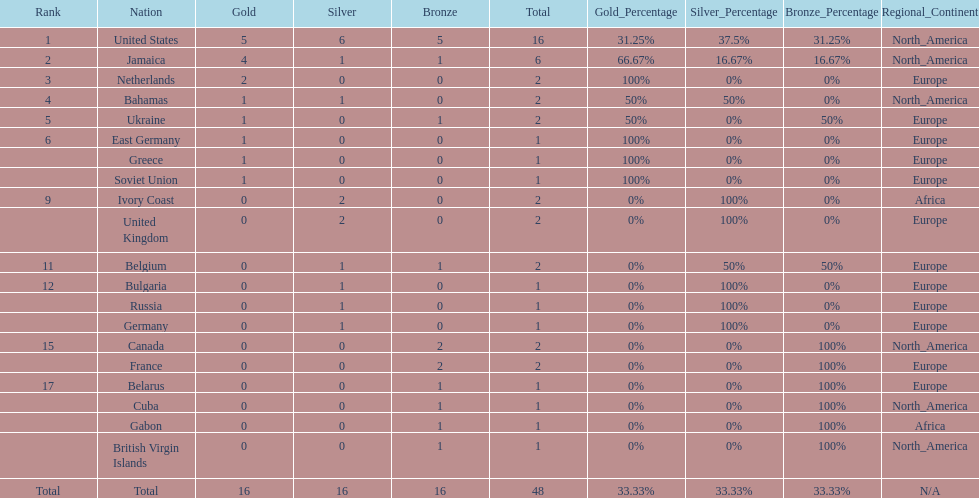How many nations won at least two gold medals? 3. 